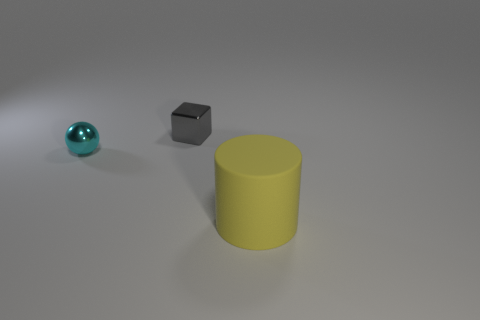Add 3 balls. How many objects exist? 6 Subtract all cubes. How many objects are left? 2 Subtract 0 red blocks. How many objects are left? 3 Subtract all small cyan metal spheres. Subtract all gray metallic things. How many objects are left? 1 Add 3 cyan balls. How many cyan balls are left? 4 Add 1 small red objects. How many small red objects exist? 1 